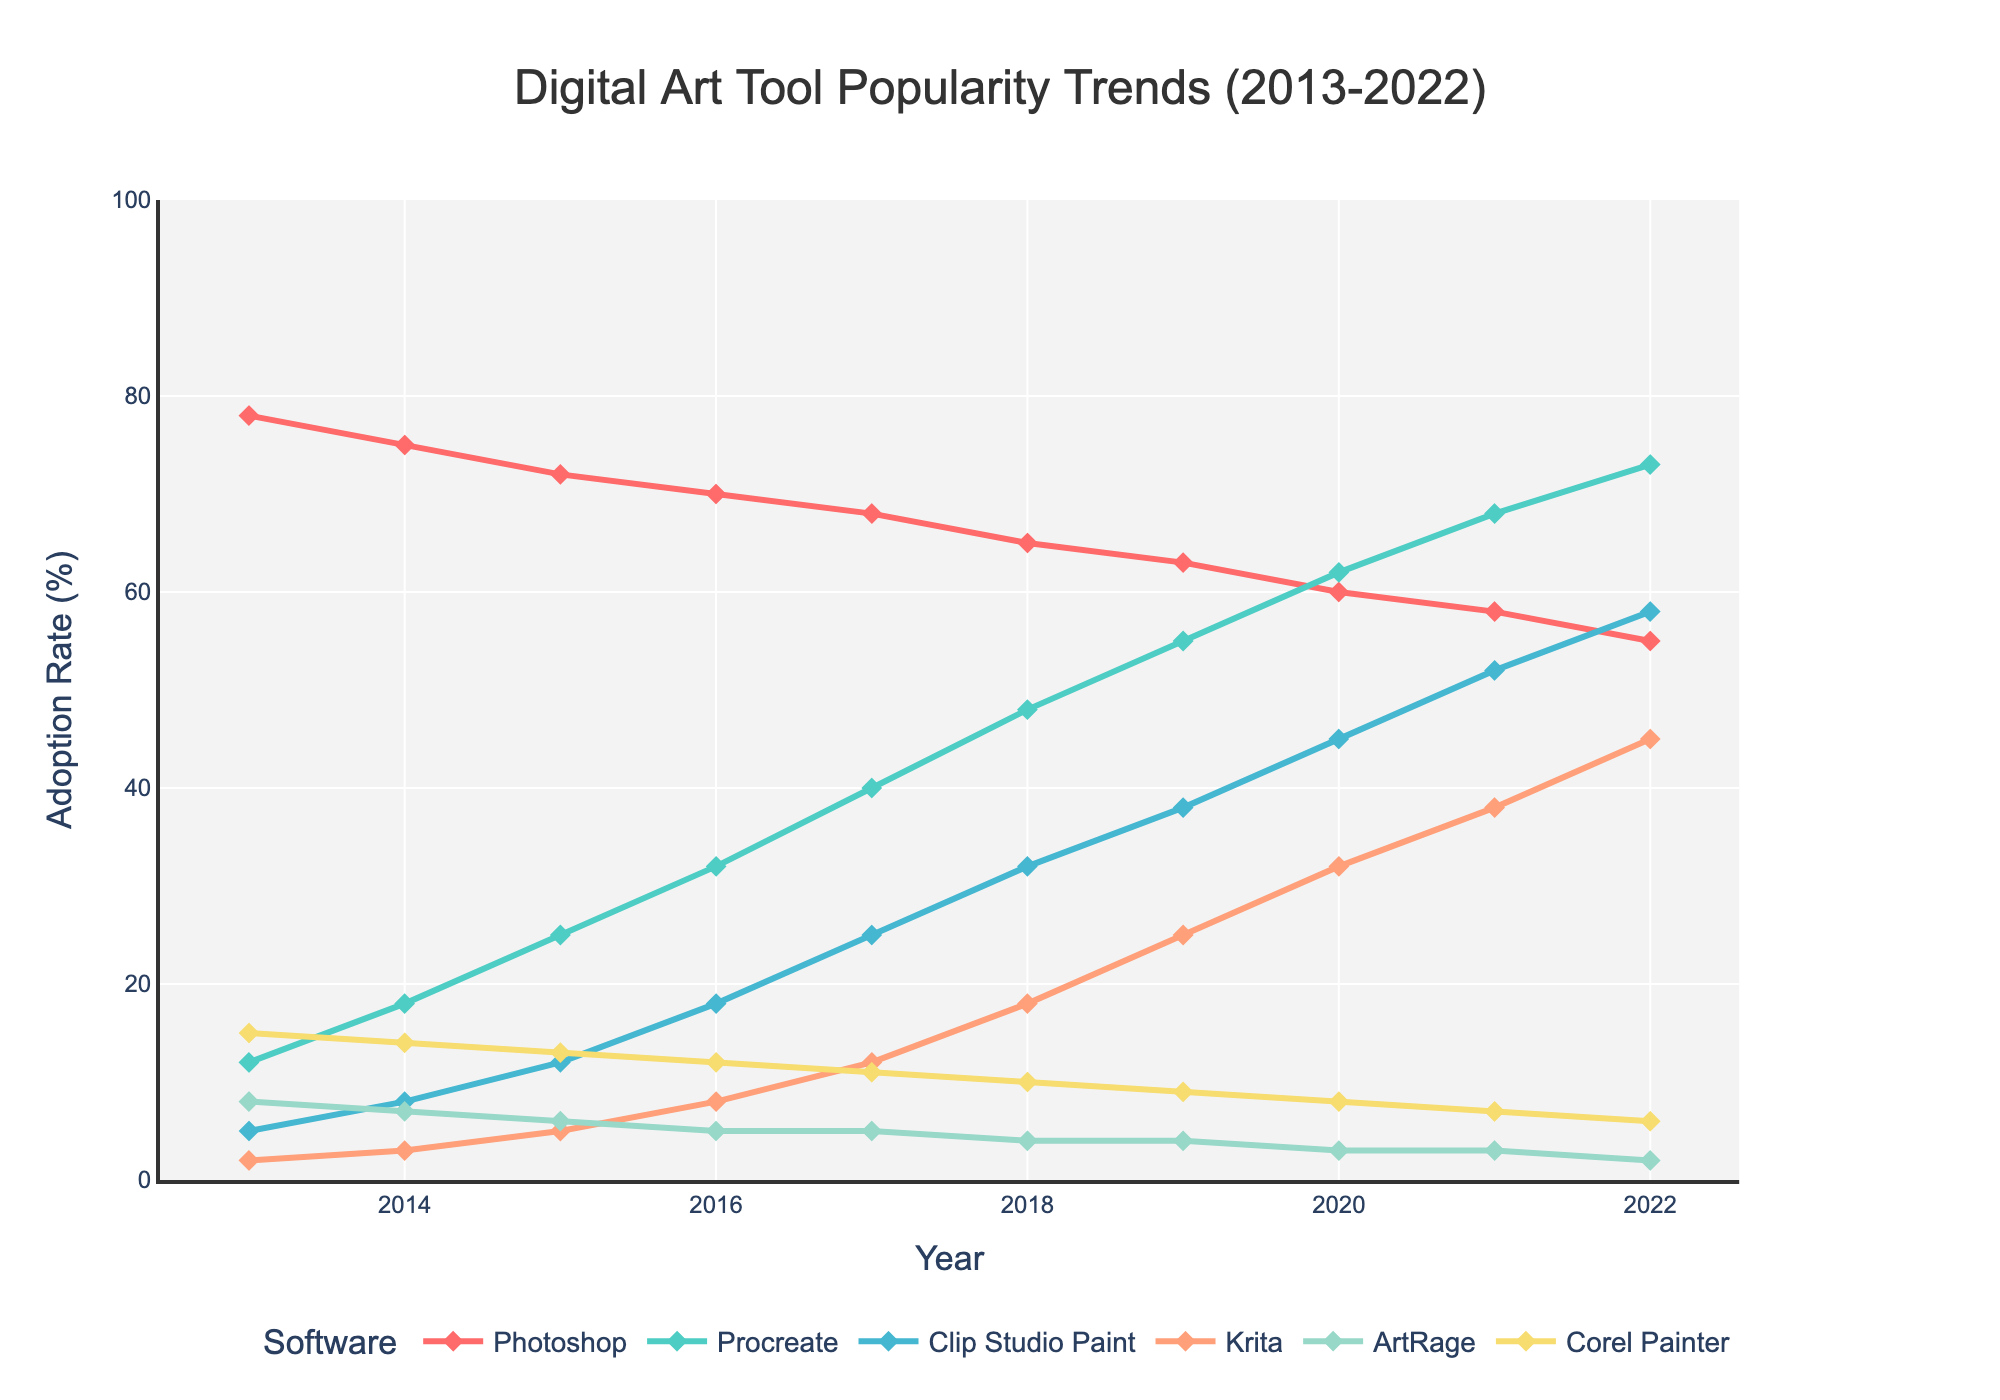What's the overall trend for Photoshop's adoption rate from 2013 to 2022? Photoshop's adoption rate shows a decreasing trend. It starts at 78% in 2013 and drops steadily each year, reaching 55% in 2022.
Answer: Decreasing Among Procreate and Krita, which one saw a more significant increase in adoption rates from 2013 to 2022? Procreate's adoption rate increased from 12% in 2013 to 73% in 2022, a 61% increase. Krita's adoption rate increased from 2% in 2013 to 45% in 2022, a 43% increase.
Answer: Procreate Calculate the average adoption rate for Clip Studio Paint over the given years. The sum of Clip Studio Paint's adoption rates from 2013 to 2022 is (5 + 8 + 12 + 18 + 25 + 32 + 38 + 45 + 52 + 58) = 293. There are 10 years, so the average is 293/10 = 29.3.
Answer: 29.3 Which software had the highest adoption rate in 2022, and what was it? By looking at the vertical positions of the lines, Photoshop had the highest adoption rate in 2022, with a rate of 55%.
Answer: Photoshop, 55% How does Corel Painter's trend compare visually to ArtRage's trend over the decade? Both Corel Painter and ArtRage show a decreasing trend, but Corel Painter's line is consistently higher than ArtRage's. Corel Painter decreases from 15% in 2013 to 6% in 2022, while ArtRage decreases from 8% to 2%.
Answer: Corel Painter is consistently higher By how much did Procreate’s adoption rate increase from 2014 to 2016? Procreate's adoption rate increased from 18% in 2014 to 32% in 2016. The increase is 32 - 18 = 14%.
Answer: 14% Compare the adoption rates of Photoshop and Clip Studio Paint in 2019. Which one had a higher rate, and by how much? In 2019, Photoshop's adoption rate was 63%, and Clip Studio Paint's adoption rate was 38%. The difference is 63 - 38 = 25%.
Answer: Photoshop, 25% What's the difference in Krita's adoption rate between the years 2015 and 2020? Krita's adoption rate in 2015 was 5%, and in 2020 it was 32%. The difference is 32 - 5 = 27%.
Answer: 27% Is there any year when ArtRage's adoption rate surpassed 5%, and if so, which years? ArtRage's adoption rate surpassed 5% in the years 2013, 2014, 2015, 2016, and 2017. In these years, the adoption rates were 8%, 7%, 6%, 5%, and 5%, respectively.
Answer: 2013-2016 